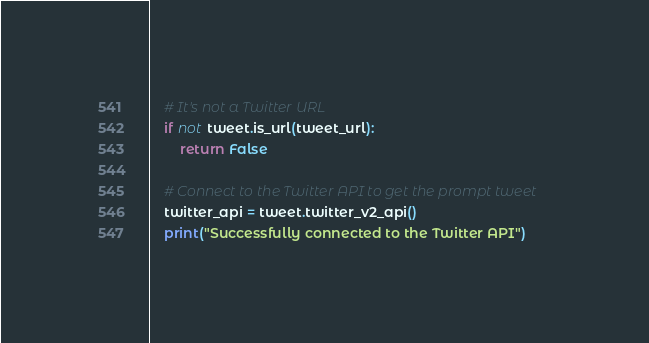<code> <loc_0><loc_0><loc_500><loc_500><_Python_>
    # It's not a Twitter URL
    if not tweet.is_url(tweet_url):
        return False

    # Connect to the Twitter API to get the prompt tweet
    twitter_api = tweet.twitter_v2_api()
    print("Successfully connected to the Twitter API")</code> 